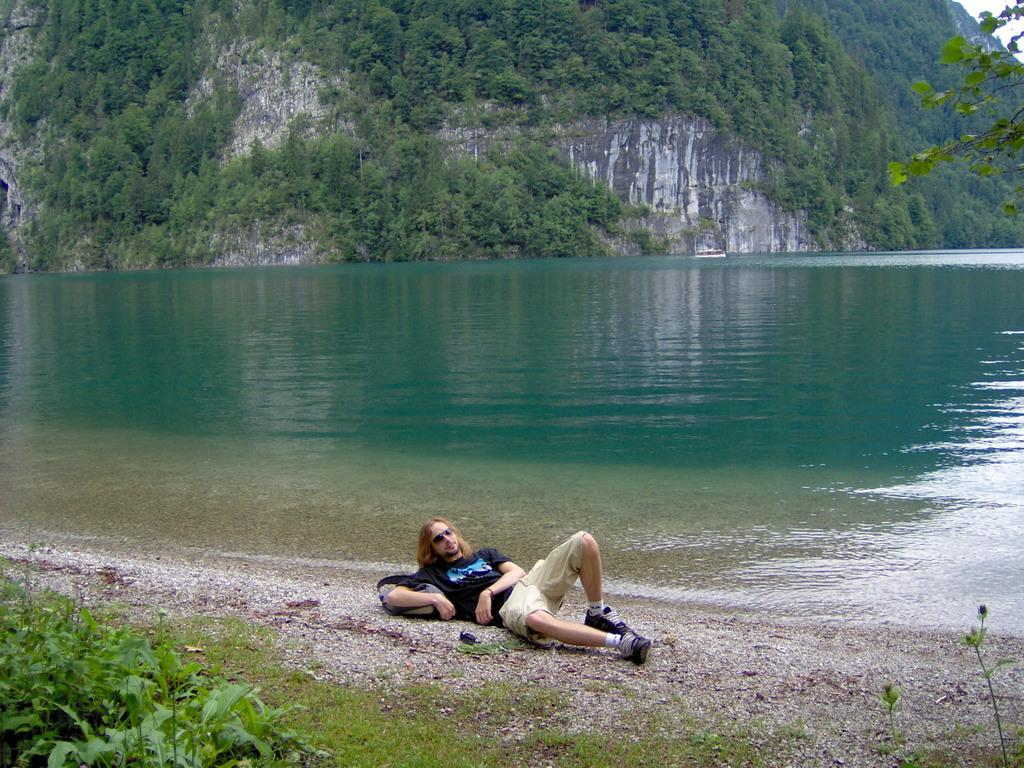What is the position of the man in the image? The man is lying down in the image. What is the man wearing on his face? The man is wearing goggles in the image. What color is the t-shirt the man is wearing? The man is wearing a black t-shirt in the image. What type of clothing is the man wearing on his lower body? The man is wearing shorts in the image. What can be seen at the front of the image? There are plants at the front of the image. What is visible in the image besides the plants? There is water visible in the image. What can be seen in the background of the image? There are trees and mountains in the background of the image. How many boats are visible in the image? There are no boats present in the image. What type of locket is the man holding in the image? There is no locket present in the image; the man is wearing goggles and a black t-shirt while lying down. 